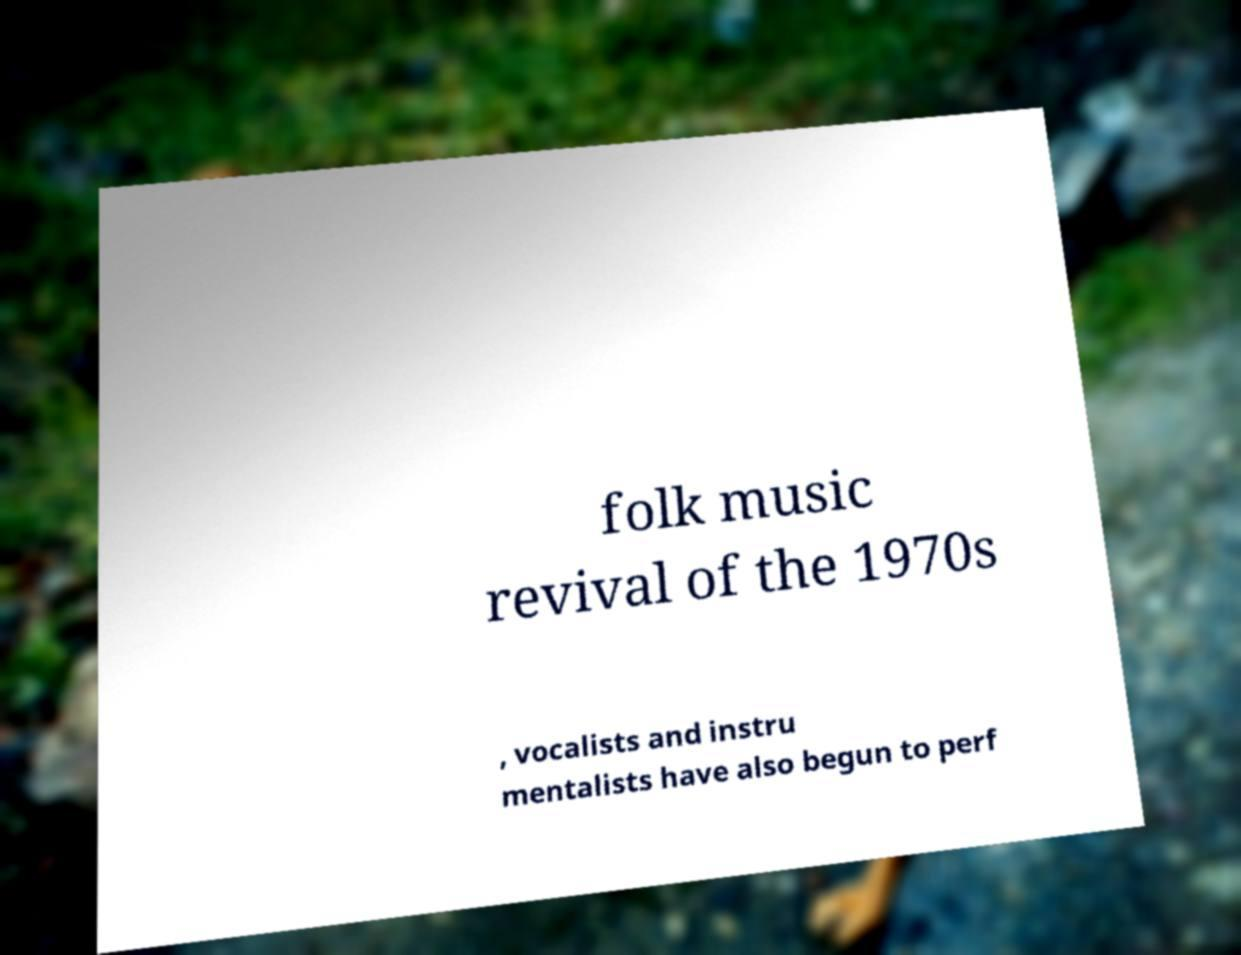What messages or text are displayed in this image? I need them in a readable, typed format. folk music revival of the 1970s , vocalists and instru mentalists have also begun to perf 